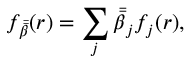Convert formula to latex. <formula><loc_0><loc_0><loc_500><loc_500>f _ { \bar { \bar { \beta } } } ( r ) = \sum _ { j } \bar { \bar { \beta } } _ { j } f _ { j } ( r ) ,</formula> 